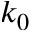<formula> <loc_0><loc_0><loc_500><loc_500>k _ { 0 }</formula> 